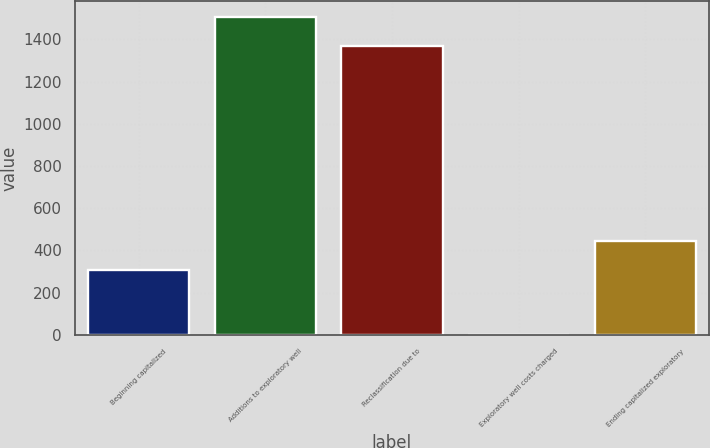Convert chart to OTSL. <chart><loc_0><loc_0><loc_500><loc_500><bar_chart><fcel>Beginning capitalized<fcel>Additions to exploratory well<fcel>Reclassification due to<fcel>Exploratory well costs charged<fcel>Ending capitalized exploratory<nl><fcel>306<fcel>1507.6<fcel>1369<fcel>1<fcel>444.6<nl></chart> 